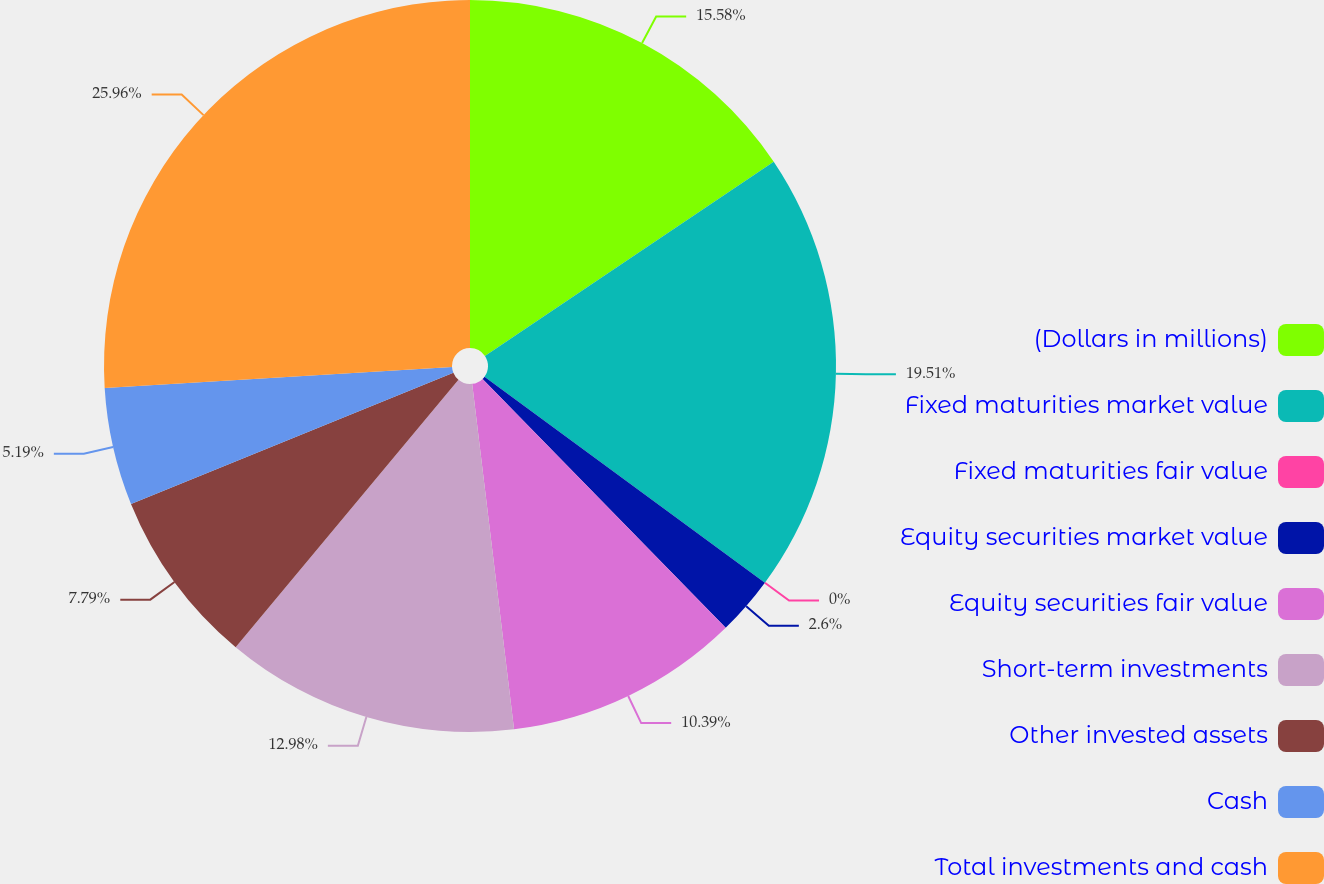Convert chart to OTSL. <chart><loc_0><loc_0><loc_500><loc_500><pie_chart><fcel>(Dollars in millions)<fcel>Fixed maturities market value<fcel>Fixed maturities fair value<fcel>Equity securities market value<fcel>Equity securities fair value<fcel>Short-term investments<fcel>Other invested assets<fcel>Cash<fcel>Total investments and cash<nl><fcel>15.58%<fcel>19.51%<fcel>0.0%<fcel>2.6%<fcel>10.39%<fcel>12.98%<fcel>7.79%<fcel>5.19%<fcel>25.96%<nl></chart> 